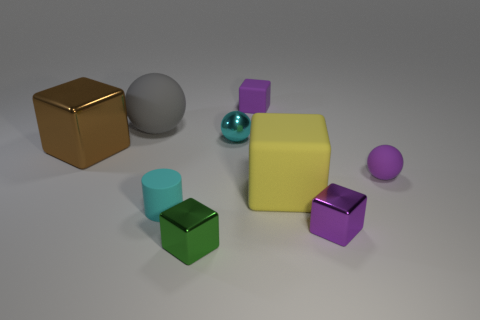Subtract all purple cubes. How many cubes are left? 3 Subtract all tiny purple shiny cubes. How many cubes are left? 4 Subtract all yellow cubes. Subtract all red balls. How many cubes are left? 4 Add 1 big purple metallic cubes. How many objects exist? 10 Subtract all cylinders. How many objects are left? 8 Subtract 1 purple spheres. How many objects are left? 8 Subtract all small purple things. Subtract all rubber objects. How many objects are left? 1 Add 2 cylinders. How many cylinders are left? 3 Add 9 large gray rubber objects. How many large gray rubber objects exist? 10 